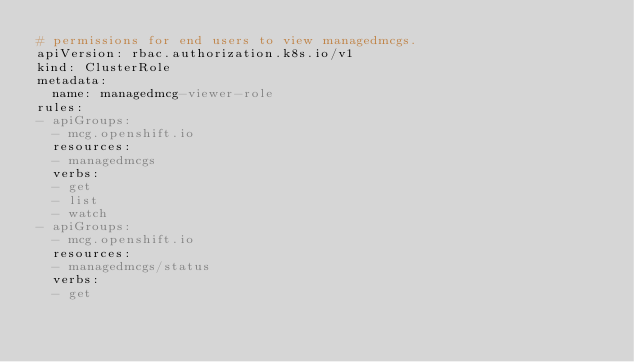Convert code to text. <code><loc_0><loc_0><loc_500><loc_500><_YAML_># permissions for end users to view managedmcgs.
apiVersion: rbac.authorization.k8s.io/v1
kind: ClusterRole
metadata:
  name: managedmcg-viewer-role
rules:
- apiGroups:
  - mcg.openshift.io
  resources:
  - managedmcgs
  verbs:
  - get
  - list
  - watch
- apiGroups:
  - mcg.openshift.io
  resources:
  - managedmcgs/status
  verbs:
  - get
</code> 